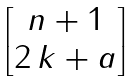<formula> <loc_0><loc_0><loc_500><loc_500>\begin{bmatrix} n + 1 \\ 2 \, k + a \end{bmatrix}</formula> 